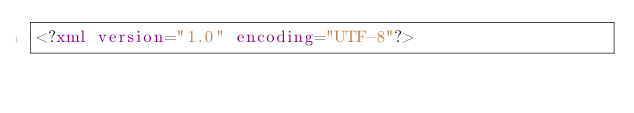Convert code to text. <code><loc_0><loc_0><loc_500><loc_500><_XML_><?xml version="1.0" encoding="UTF-8"?></code> 